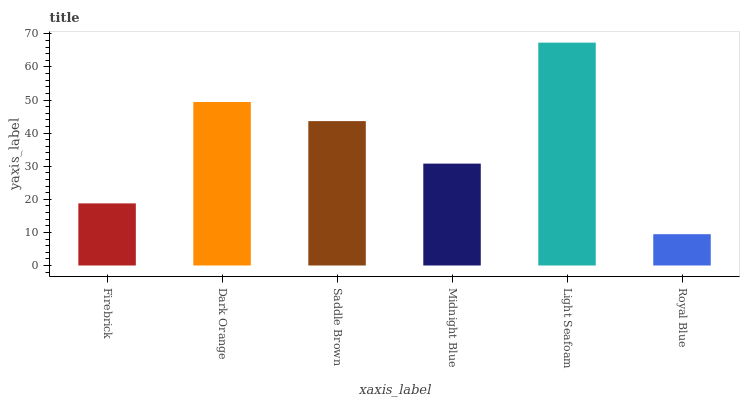Is Light Seafoam the maximum?
Answer yes or no. Yes. Is Dark Orange the minimum?
Answer yes or no. No. Is Dark Orange the maximum?
Answer yes or no. No. Is Dark Orange greater than Firebrick?
Answer yes or no. Yes. Is Firebrick less than Dark Orange?
Answer yes or no. Yes. Is Firebrick greater than Dark Orange?
Answer yes or no. No. Is Dark Orange less than Firebrick?
Answer yes or no. No. Is Saddle Brown the high median?
Answer yes or no. Yes. Is Midnight Blue the low median?
Answer yes or no. Yes. Is Dark Orange the high median?
Answer yes or no. No. Is Royal Blue the low median?
Answer yes or no. No. 